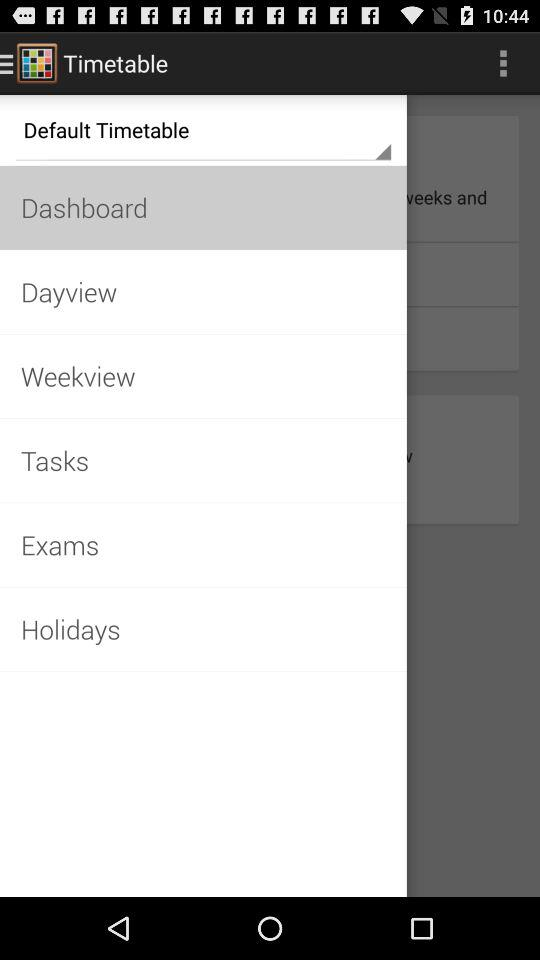What is the application name? The application name is "Timetable". 